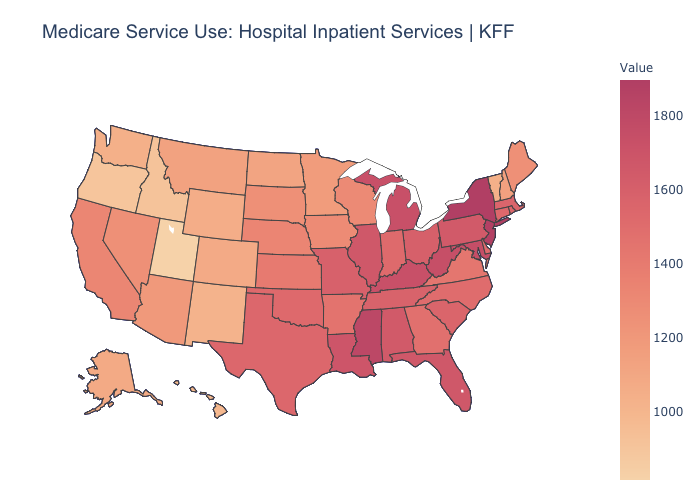Which states have the lowest value in the West?
Quick response, please. Utah. Does Mississippi have a lower value than Nebraska?
Answer briefly. No. Which states have the highest value in the USA?
Give a very brief answer. New York. Is the legend a continuous bar?
Answer briefly. Yes. 